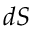Convert formula to latex. <formula><loc_0><loc_0><loc_500><loc_500>d S</formula> 